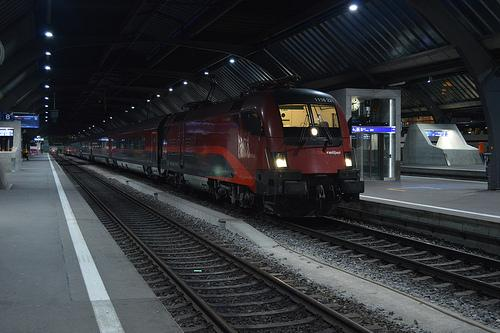Identify the main colors present on the train and indicate the location of any text or signage. Main colors are red, black, and a bit of white. White numbers can be seen on the red part of the train. Choose an object in the image that is not directly related to the train itself, and provide a brief description. There is a blue sign on a metal pole in the train station. What are some of the notable structural elements that can be observed in the train station? A long train station walkway, a long row of lights on the roof, and a thin purple sign. Identify the primary vehicle in the image and specify its color. The primary vehicle is a long red train. Explain the appearance of the train's headlights and any additional illumination features. The train has two illuminated square headlights on the bottom, and a red train's left headlight that is also illuminated. From the perspective of a product advertisement, describe an element in the image that could be marketed as a selling feature. The headlights of the red train are a standout feature, providing superior illumination for safe and efficient travel during nighttime operations. In the image, what is the location of the train? The train is inside a train station, picking up passengers on the train tracks. List three observable characteristics of the train in the image. The train is red and black, has illuminated headlights, and white numbers on its side. Describe the features related to the train tracks and their surroundings in the image. There are long black train tracks, gravel between the train tracks, and a pedestrian walkway beside the train tracks. What small, unexpected detail can be observed in the image involving a person? There is a man sitting in a chair on the pedestrian walkway. 